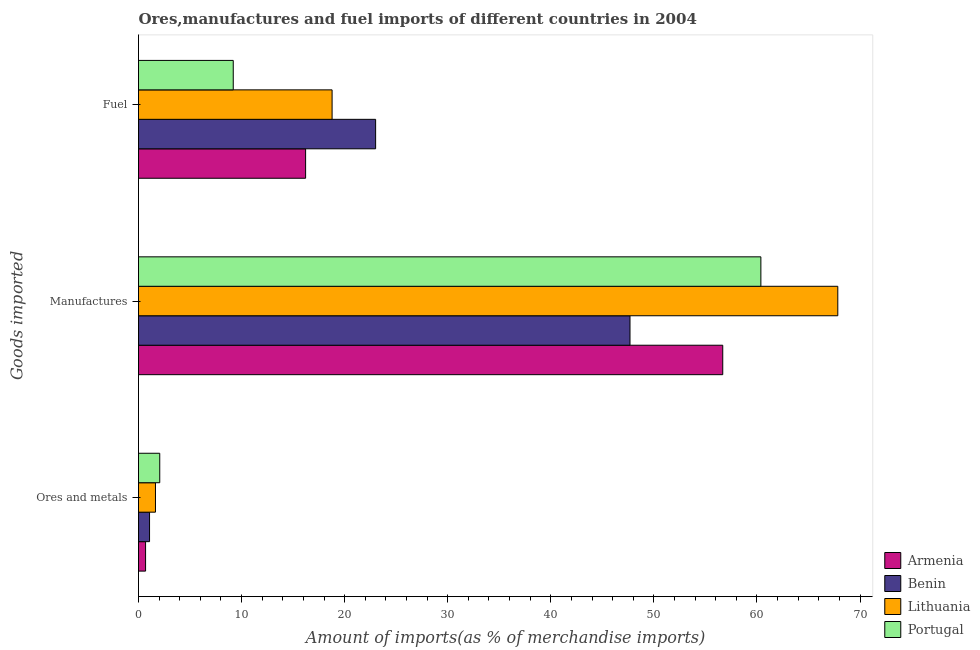How many groups of bars are there?
Provide a succinct answer. 3. Are the number of bars on each tick of the Y-axis equal?
Your response must be concise. Yes. How many bars are there on the 1st tick from the top?
Give a very brief answer. 4. How many bars are there on the 3rd tick from the bottom?
Your response must be concise. 4. What is the label of the 3rd group of bars from the top?
Offer a very short reply. Ores and metals. What is the percentage of ores and metals imports in Armenia?
Offer a very short reply. 0.69. Across all countries, what is the maximum percentage of ores and metals imports?
Make the answer very short. 2.06. Across all countries, what is the minimum percentage of ores and metals imports?
Offer a terse response. 0.69. In which country was the percentage of ores and metals imports minimum?
Your answer should be very brief. Armenia. What is the total percentage of ores and metals imports in the graph?
Provide a short and direct response. 5.46. What is the difference between the percentage of ores and metals imports in Armenia and that in Benin?
Your answer should be very brief. -0.39. What is the difference between the percentage of fuel imports in Lithuania and the percentage of ores and metals imports in Armenia?
Your answer should be very brief. 18.1. What is the average percentage of fuel imports per country?
Provide a short and direct response. 16.8. What is the difference between the percentage of fuel imports and percentage of manufactures imports in Lithuania?
Make the answer very short. -49.06. What is the ratio of the percentage of manufactures imports in Lithuania to that in Armenia?
Offer a terse response. 1.2. Is the difference between the percentage of fuel imports in Portugal and Armenia greater than the difference between the percentage of manufactures imports in Portugal and Armenia?
Provide a succinct answer. No. What is the difference between the highest and the second highest percentage of manufactures imports?
Make the answer very short. 7.46. What is the difference between the highest and the lowest percentage of fuel imports?
Give a very brief answer. 13.81. What does the 2nd bar from the top in Ores and metals represents?
Keep it short and to the point. Lithuania. What does the 2nd bar from the bottom in Manufactures represents?
Give a very brief answer. Benin. Is it the case that in every country, the sum of the percentage of ores and metals imports and percentage of manufactures imports is greater than the percentage of fuel imports?
Ensure brevity in your answer.  Yes. Are all the bars in the graph horizontal?
Ensure brevity in your answer.  Yes. How many countries are there in the graph?
Your answer should be compact. 4. What is the difference between two consecutive major ticks on the X-axis?
Make the answer very short. 10. Where does the legend appear in the graph?
Your answer should be very brief. Bottom right. How are the legend labels stacked?
Offer a terse response. Vertical. What is the title of the graph?
Provide a short and direct response. Ores,manufactures and fuel imports of different countries in 2004. Does "France" appear as one of the legend labels in the graph?
Give a very brief answer. No. What is the label or title of the X-axis?
Your answer should be very brief. Amount of imports(as % of merchandise imports). What is the label or title of the Y-axis?
Keep it short and to the point. Goods imported. What is the Amount of imports(as % of merchandise imports) of Armenia in Ores and metals?
Provide a succinct answer. 0.69. What is the Amount of imports(as % of merchandise imports) in Benin in Ores and metals?
Provide a succinct answer. 1.07. What is the Amount of imports(as % of merchandise imports) of Lithuania in Ores and metals?
Ensure brevity in your answer.  1.64. What is the Amount of imports(as % of merchandise imports) in Portugal in Ores and metals?
Your answer should be compact. 2.06. What is the Amount of imports(as % of merchandise imports) in Armenia in Manufactures?
Offer a terse response. 56.68. What is the Amount of imports(as % of merchandise imports) in Benin in Manufactures?
Keep it short and to the point. 47.69. What is the Amount of imports(as % of merchandise imports) in Lithuania in Manufactures?
Offer a very short reply. 67.85. What is the Amount of imports(as % of merchandise imports) of Portugal in Manufactures?
Keep it short and to the point. 60.38. What is the Amount of imports(as % of merchandise imports) in Armenia in Fuel?
Offer a terse response. 16.21. What is the Amount of imports(as % of merchandise imports) of Benin in Fuel?
Provide a succinct answer. 23.01. What is the Amount of imports(as % of merchandise imports) of Lithuania in Fuel?
Your answer should be compact. 18.78. What is the Amount of imports(as % of merchandise imports) in Portugal in Fuel?
Your answer should be compact. 9.19. Across all Goods imported, what is the maximum Amount of imports(as % of merchandise imports) in Armenia?
Your answer should be very brief. 56.68. Across all Goods imported, what is the maximum Amount of imports(as % of merchandise imports) of Benin?
Keep it short and to the point. 47.69. Across all Goods imported, what is the maximum Amount of imports(as % of merchandise imports) of Lithuania?
Provide a short and direct response. 67.85. Across all Goods imported, what is the maximum Amount of imports(as % of merchandise imports) of Portugal?
Make the answer very short. 60.38. Across all Goods imported, what is the minimum Amount of imports(as % of merchandise imports) in Armenia?
Give a very brief answer. 0.69. Across all Goods imported, what is the minimum Amount of imports(as % of merchandise imports) in Benin?
Your answer should be compact. 1.07. Across all Goods imported, what is the minimum Amount of imports(as % of merchandise imports) in Lithuania?
Your response must be concise. 1.64. Across all Goods imported, what is the minimum Amount of imports(as % of merchandise imports) of Portugal?
Keep it short and to the point. 2.06. What is the total Amount of imports(as % of merchandise imports) in Armenia in the graph?
Your answer should be compact. 73.58. What is the total Amount of imports(as % of merchandise imports) of Benin in the graph?
Make the answer very short. 71.76. What is the total Amount of imports(as % of merchandise imports) of Lithuania in the graph?
Your answer should be compact. 88.27. What is the total Amount of imports(as % of merchandise imports) of Portugal in the graph?
Provide a succinct answer. 71.64. What is the difference between the Amount of imports(as % of merchandise imports) of Armenia in Ores and metals and that in Manufactures?
Keep it short and to the point. -56. What is the difference between the Amount of imports(as % of merchandise imports) of Benin in Ores and metals and that in Manufactures?
Offer a terse response. -46.61. What is the difference between the Amount of imports(as % of merchandise imports) in Lithuania in Ores and metals and that in Manufactures?
Provide a succinct answer. -66.2. What is the difference between the Amount of imports(as % of merchandise imports) of Portugal in Ores and metals and that in Manufactures?
Your answer should be compact. -58.32. What is the difference between the Amount of imports(as % of merchandise imports) in Armenia in Ores and metals and that in Fuel?
Make the answer very short. -15.53. What is the difference between the Amount of imports(as % of merchandise imports) in Benin in Ores and metals and that in Fuel?
Provide a succinct answer. -21.93. What is the difference between the Amount of imports(as % of merchandise imports) of Lithuania in Ores and metals and that in Fuel?
Your answer should be very brief. -17.14. What is the difference between the Amount of imports(as % of merchandise imports) in Portugal in Ores and metals and that in Fuel?
Your answer should be compact. -7.13. What is the difference between the Amount of imports(as % of merchandise imports) of Armenia in Manufactures and that in Fuel?
Give a very brief answer. 40.47. What is the difference between the Amount of imports(as % of merchandise imports) of Benin in Manufactures and that in Fuel?
Your answer should be very brief. 24.68. What is the difference between the Amount of imports(as % of merchandise imports) of Lithuania in Manufactures and that in Fuel?
Your response must be concise. 49.06. What is the difference between the Amount of imports(as % of merchandise imports) of Portugal in Manufactures and that in Fuel?
Your answer should be compact. 51.19. What is the difference between the Amount of imports(as % of merchandise imports) of Armenia in Ores and metals and the Amount of imports(as % of merchandise imports) of Benin in Manufactures?
Provide a succinct answer. -47. What is the difference between the Amount of imports(as % of merchandise imports) of Armenia in Ores and metals and the Amount of imports(as % of merchandise imports) of Lithuania in Manufactures?
Offer a terse response. -67.16. What is the difference between the Amount of imports(as % of merchandise imports) of Armenia in Ores and metals and the Amount of imports(as % of merchandise imports) of Portugal in Manufactures?
Make the answer very short. -59.7. What is the difference between the Amount of imports(as % of merchandise imports) of Benin in Ores and metals and the Amount of imports(as % of merchandise imports) of Lithuania in Manufactures?
Your response must be concise. -66.77. What is the difference between the Amount of imports(as % of merchandise imports) of Benin in Ores and metals and the Amount of imports(as % of merchandise imports) of Portugal in Manufactures?
Your response must be concise. -59.31. What is the difference between the Amount of imports(as % of merchandise imports) in Lithuania in Ores and metals and the Amount of imports(as % of merchandise imports) in Portugal in Manufactures?
Your answer should be compact. -58.74. What is the difference between the Amount of imports(as % of merchandise imports) in Armenia in Ores and metals and the Amount of imports(as % of merchandise imports) in Benin in Fuel?
Provide a succinct answer. -22.32. What is the difference between the Amount of imports(as % of merchandise imports) in Armenia in Ores and metals and the Amount of imports(as % of merchandise imports) in Lithuania in Fuel?
Your answer should be compact. -18.1. What is the difference between the Amount of imports(as % of merchandise imports) of Armenia in Ores and metals and the Amount of imports(as % of merchandise imports) of Portugal in Fuel?
Ensure brevity in your answer.  -8.51. What is the difference between the Amount of imports(as % of merchandise imports) in Benin in Ores and metals and the Amount of imports(as % of merchandise imports) in Lithuania in Fuel?
Make the answer very short. -17.71. What is the difference between the Amount of imports(as % of merchandise imports) of Benin in Ores and metals and the Amount of imports(as % of merchandise imports) of Portugal in Fuel?
Provide a short and direct response. -8.12. What is the difference between the Amount of imports(as % of merchandise imports) of Lithuania in Ores and metals and the Amount of imports(as % of merchandise imports) of Portugal in Fuel?
Offer a terse response. -7.55. What is the difference between the Amount of imports(as % of merchandise imports) of Armenia in Manufactures and the Amount of imports(as % of merchandise imports) of Benin in Fuel?
Ensure brevity in your answer.  33.68. What is the difference between the Amount of imports(as % of merchandise imports) of Armenia in Manufactures and the Amount of imports(as % of merchandise imports) of Lithuania in Fuel?
Provide a succinct answer. 37.9. What is the difference between the Amount of imports(as % of merchandise imports) of Armenia in Manufactures and the Amount of imports(as % of merchandise imports) of Portugal in Fuel?
Keep it short and to the point. 47.49. What is the difference between the Amount of imports(as % of merchandise imports) in Benin in Manufactures and the Amount of imports(as % of merchandise imports) in Lithuania in Fuel?
Your response must be concise. 28.9. What is the difference between the Amount of imports(as % of merchandise imports) of Benin in Manufactures and the Amount of imports(as % of merchandise imports) of Portugal in Fuel?
Give a very brief answer. 38.49. What is the difference between the Amount of imports(as % of merchandise imports) of Lithuania in Manufactures and the Amount of imports(as % of merchandise imports) of Portugal in Fuel?
Your answer should be compact. 58.65. What is the average Amount of imports(as % of merchandise imports) of Armenia per Goods imported?
Your response must be concise. 24.53. What is the average Amount of imports(as % of merchandise imports) in Benin per Goods imported?
Offer a terse response. 23.92. What is the average Amount of imports(as % of merchandise imports) of Lithuania per Goods imported?
Offer a very short reply. 29.42. What is the average Amount of imports(as % of merchandise imports) of Portugal per Goods imported?
Your answer should be very brief. 23.88. What is the difference between the Amount of imports(as % of merchandise imports) in Armenia and Amount of imports(as % of merchandise imports) in Benin in Ores and metals?
Provide a short and direct response. -0.39. What is the difference between the Amount of imports(as % of merchandise imports) in Armenia and Amount of imports(as % of merchandise imports) in Lithuania in Ores and metals?
Give a very brief answer. -0.96. What is the difference between the Amount of imports(as % of merchandise imports) of Armenia and Amount of imports(as % of merchandise imports) of Portugal in Ores and metals?
Keep it short and to the point. -1.37. What is the difference between the Amount of imports(as % of merchandise imports) in Benin and Amount of imports(as % of merchandise imports) in Lithuania in Ores and metals?
Give a very brief answer. -0.57. What is the difference between the Amount of imports(as % of merchandise imports) of Benin and Amount of imports(as % of merchandise imports) of Portugal in Ores and metals?
Offer a terse response. -0.99. What is the difference between the Amount of imports(as % of merchandise imports) of Lithuania and Amount of imports(as % of merchandise imports) of Portugal in Ores and metals?
Offer a terse response. -0.42. What is the difference between the Amount of imports(as % of merchandise imports) in Armenia and Amount of imports(as % of merchandise imports) in Benin in Manufactures?
Provide a succinct answer. 9. What is the difference between the Amount of imports(as % of merchandise imports) of Armenia and Amount of imports(as % of merchandise imports) of Lithuania in Manufactures?
Provide a succinct answer. -11.16. What is the difference between the Amount of imports(as % of merchandise imports) in Armenia and Amount of imports(as % of merchandise imports) in Portugal in Manufactures?
Offer a very short reply. -3.7. What is the difference between the Amount of imports(as % of merchandise imports) in Benin and Amount of imports(as % of merchandise imports) in Lithuania in Manufactures?
Provide a succinct answer. -20.16. What is the difference between the Amount of imports(as % of merchandise imports) in Benin and Amount of imports(as % of merchandise imports) in Portugal in Manufactures?
Your response must be concise. -12.7. What is the difference between the Amount of imports(as % of merchandise imports) of Lithuania and Amount of imports(as % of merchandise imports) of Portugal in Manufactures?
Give a very brief answer. 7.46. What is the difference between the Amount of imports(as % of merchandise imports) in Armenia and Amount of imports(as % of merchandise imports) in Benin in Fuel?
Ensure brevity in your answer.  -6.79. What is the difference between the Amount of imports(as % of merchandise imports) in Armenia and Amount of imports(as % of merchandise imports) in Lithuania in Fuel?
Provide a short and direct response. -2.57. What is the difference between the Amount of imports(as % of merchandise imports) in Armenia and Amount of imports(as % of merchandise imports) in Portugal in Fuel?
Give a very brief answer. 7.02. What is the difference between the Amount of imports(as % of merchandise imports) of Benin and Amount of imports(as % of merchandise imports) of Lithuania in Fuel?
Provide a succinct answer. 4.22. What is the difference between the Amount of imports(as % of merchandise imports) in Benin and Amount of imports(as % of merchandise imports) in Portugal in Fuel?
Your answer should be compact. 13.81. What is the difference between the Amount of imports(as % of merchandise imports) in Lithuania and Amount of imports(as % of merchandise imports) in Portugal in Fuel?
Give a very brief answer. 9.59. What is the ratio of the Amount of imports(as % of merchandise imports) in Armenia in Ores and metals to that in Manufactures?
Offer a terse response. 0.01. What is the ratio of the Amount of imports(as % of merchandise imports) in Benin in Ores and metals to that in Manufactures?
Offer a terse response. 0.02. What is the ratio of the Amount of imports(as % of merchandise imports) in Lithuania in Ores and metals to that in Manufactures?
Offer a very short reply. 0.02. What is the ratio of the Amount of imports(as % of merchandise imports) in Portugal in Ores and metals to that in Manufactures?
Your answer should be compact. 0.03. What is the ratio of the Amount of imports(as % of merchandise imports) of Armenia in Ores and metals to that in Fuel?
Your answer should be compact. 0.04. What is the ratio of the Amount of imports(as % of merchandise imports) in Benin in Ores and metals to that in Fuel?
Your answer should be very brief. 0.05. What is the ratio of the Amount of imports(as % of merchandise imports) of Lithuania in Ores and metals to that in Fuel?
Provide a succinct answer. 0.09. What is the ratio of the Amount of imports(as % of merchandise imports) in Portugal in Ores and metals to that in Fuel?
Provide a succinct answer. 0.22. What is the ratio of the Amount of imports(as % of merchandise imports) in Armenia in Manufactures to that in Fuel?
Your response must be concise. 3.5. What is the ratio of the Amount of imports(as % of merchandise imports) of Benin in Manufactures to that in Fuel?
Provide a short and direct response. 2.07. What is the ratio of the Amount of imports(as % of merchandise imports) of Lithuania in Manufactures to that in Fuel?
Keep it short and to the point. 3.61. What is the ratio of the Amount of imports(as % of merchandise imports) in Portugal in Manufactures to that in Fuel?
Provide a short and direct response. 6.57. What is the difference between the highest and the second highest Amount of imports(as % of merchandise imports) of Armenia?
Offer a terse response. 40.47. What is the difference between the highest and the second highest Amount of imports(as % of merchandise imports) of Benin?
Your answer should be compact. 24.68. What is the difference between the highest and the second highest Amount of imports(as % of merchandise imports) in Lithuania?
Give a very brief answer. 49.06. What is the difference between the highest and the second highest Amount of imports(as % of merchandise imports) of Portugal?
Make the answer very short. 51.19. What is the difference between the highest and the lowest Amount of imports(as % of merchandise imports) of Armenia?
Offer a terse response. 56. What is the difference between the highest and the lowest Amount of imports(as % of merchandise imports) in Benin?
Give a very brief answer. 46.61. What is the difference between the highest and the lowest Amount of imports(as % of merchandise imports) of Lithuania?
Your answer should be very brief. 66.2. What is the difference between the highest and the lowest Amount of imports(as % of merchandise imports) in Portugal?
Provide a succinct answer. 58.32. 